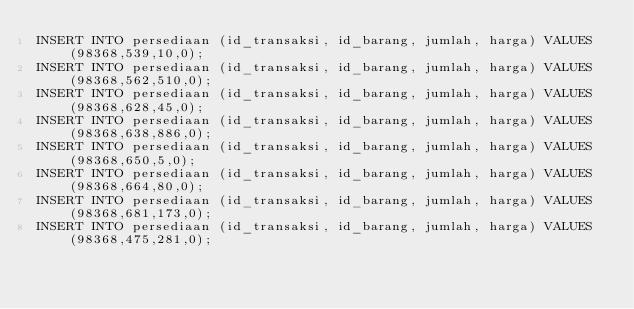Convert code to text. <code><loc_0><loc_0><loc_500><loc_500><_SQL_>INSERT INTO persediaan (id_transaksi, id_barang, jumlah, harga) VALUES (98368,539,10,0);
INSERT INTO persediaan (id_transaksi, id_barang, jumlah, harga) VALUES (98368,562,510,0);
INSERT INTO persediaan (id_transaksi, id_barang, jumlah, harga) VALUES (98368,628,45,0);
INSERT INTO persediaan (id_transaksi, id_barang, jumlah, harga) VALUES (98368,638,886,0);
INSERT INTO persediaan (id_transaksi, id_barang, jumlah, harga) VALUES (98368,650,5,0);
INSERT INTO persediaan (id_transaksi, id_barang, jumlah, harga) VALUES (98368,664,80,0);
INSERT INTO persediaan (id_transaksi, id_barang, jumlah, harga) VALUES (98368,681,173,0);
INSERT INTO persediaan (id_transaksi, id_barang, jumlah, harga) VALUES (98368,475,281,0);</code> 